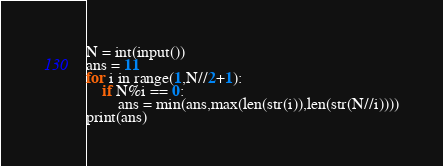<code> <loc_0><loc_0><loc_500><loc_500><_Python_>N = int(input())
ans = 11
for i in range(1,N//2+1):
    if N%i == 0:
        ans = min(ans,max(len(str(i)),len(str(N//i))))
print(ans)</code> 